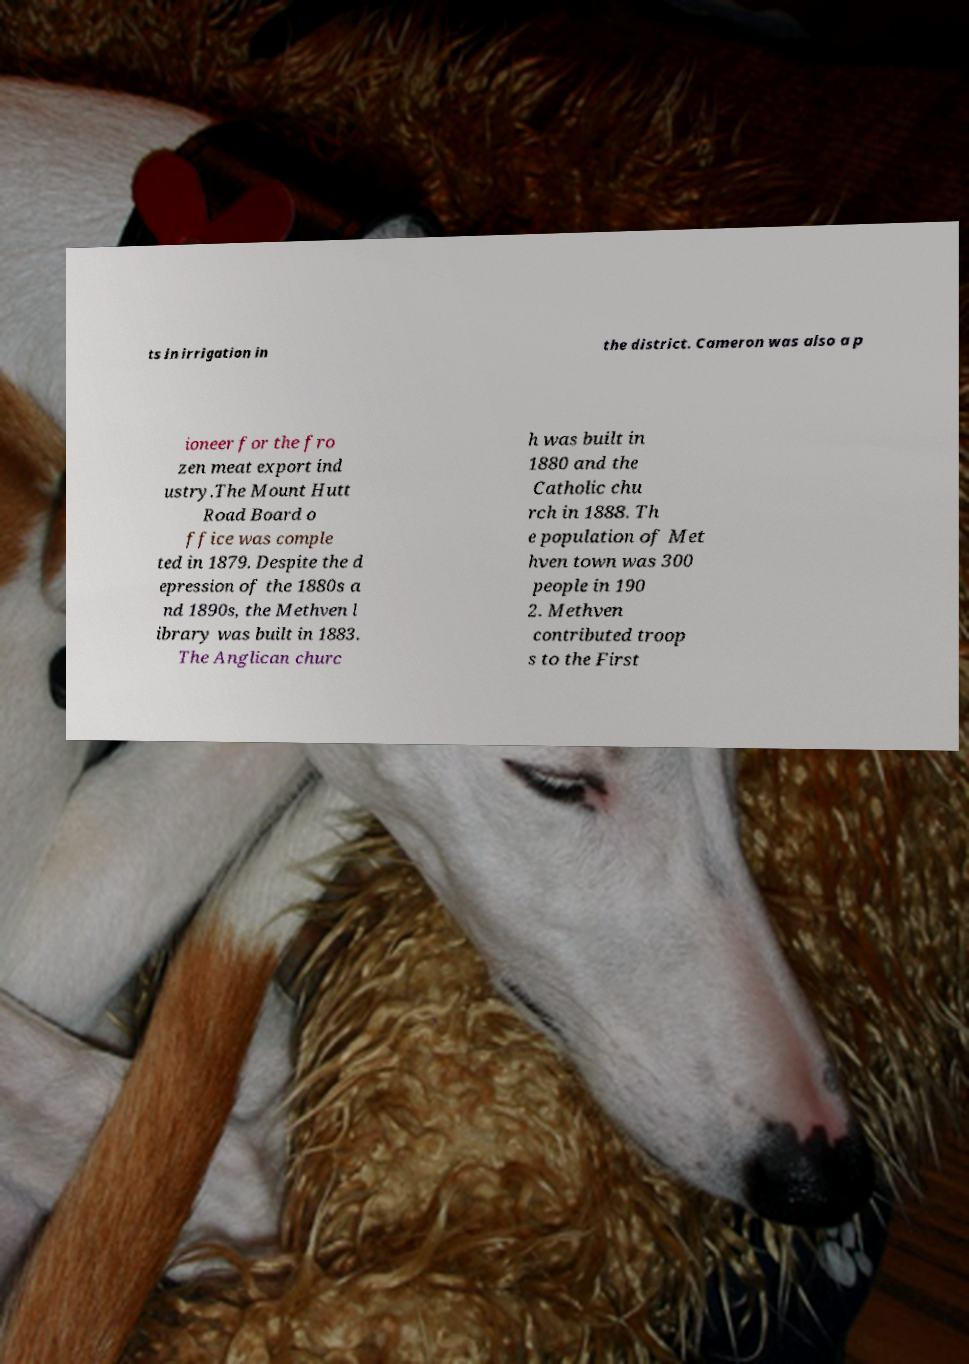Please identify and transcribe the text found in this image. ts in irrigation in the district. Cameron was also a p ioneer for the fro zen meat export ind ustry.The Mount Hutt Road Board o ffice was comple ted in 1879. Despite the d epression of the 1880s a nd 1890s, the Methven l ibrary was built in 1883. The Anglican churc h was built in 1880 and the Catholic chu rch in 1888. Th e population of Met hven town was 300 people in 190 2. Methven contributed troop s to the First 